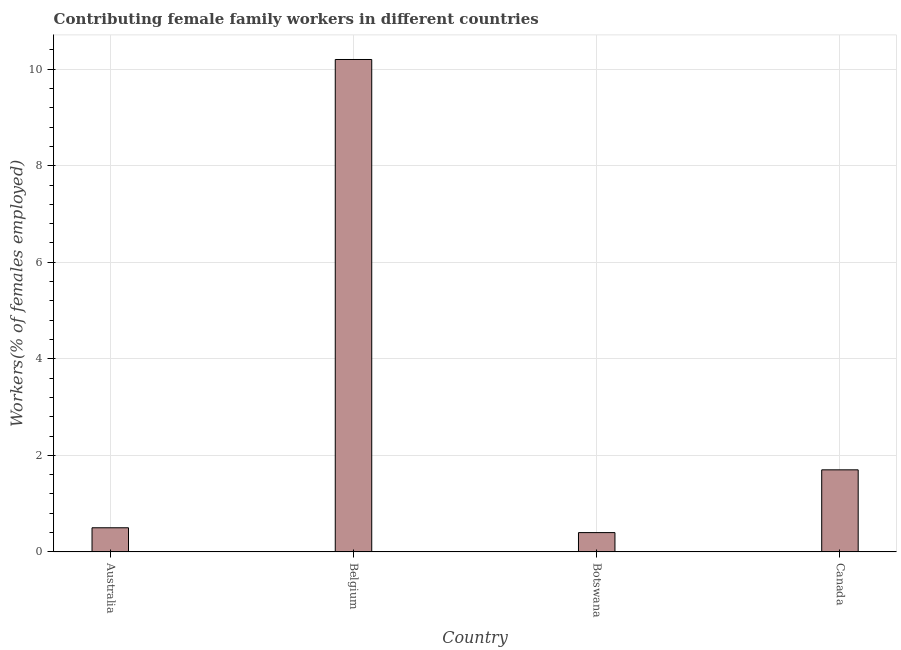What is the title of the graph?
Give a very brief answer. Contributing female family workers in different countries. What is the label or title of the Y-axis?
Offer a very short reply. Workers(% of females employed). What is the contributing female family workers in Botswana?
Your answer should be compact. 0.4. Across all countries, what is the maximum contributing female family workers?
Offer a very short reply. 10.2. Across all countries, what is the minimum contributing female family workers?
Offer a very short reply. 0.4. In which country was the contributing female family workers minimum?
Make the answer very short. Botswana. What is the sum of the contributing female family workers?
Your answer should be compact. 12.8. What is the difference between the contributing female family workers in Australia and Canada?
Keep it short and to the point. -1.2. What is the median contributing female family workers?
Keep it short and to the point. 1.1. What is the ratio of the contributing female family workers in Australia to that in Canada?
Keep it short and to the point. 0.29. Is the difference between the contributing female family workers in Belgium and Botswana greater than the difference between any two countries?
Make the answer very short. Yes. What is the difference between the highest and the second highest contributing female family workers?
Keep it short and to the point. 8.5. Is the sum of the contributing female family workers in Belgium and Canada greater than the maximum contributing female family workers across all countries?
Your answer should be compact. Yes. How many bars are there?
Provide a short and direct response. 4. Are all the bars in the graph horizontal?
Your answer should be compact. No. How many countries are there in the graph?
Your answer should be very brief. 4. What is the difference between two consecutive major ticks on the Y-axis?
Offer a terse response. 2. Are the values on the major ticks of Y-axis written in scientific E-notation?
Your answer should be very brief. No. What is the Workers(% of females employed) of Australia?
Give a very brief answer. 0.5. What is the Workers(% of females employed) of Belgium?
Your answer should be compact. 10.2. What is the Workers(% of females employed) of Botswana?
Provide a short and direct response. 0.4. What is the Workers(% of females employed) of Canada?
Offer a very short reply. 1.7. What is the difference between the Workers(% of females employed) in Australia and Canada?
Make the answer very short. -1.2. What is the difference between the Workers(% of females employed) in Botswana and Canada?
Your answer should be very brief. -1.3. What is the ratio of the Workers(% of females employed) in Australia to that in Belgium?
Your answer should be compact. 0.05. What is the ratio of the Workers(% of females employed) in Australia to that in Botswana?
Your answer should be compact. 1.25. What is the ratio of the Workers(% of females employed) in Australia to that in Canada?
Make the answer very short. 0.29. What is the ratio of the Workers(% of females employed) in Belgium to that in Canada?
Provide a succinct answer. 6. What is the ratio of the Workers(% of females employed) in Botswana to that in Canada?
Offer a very short reply. 0.23. 